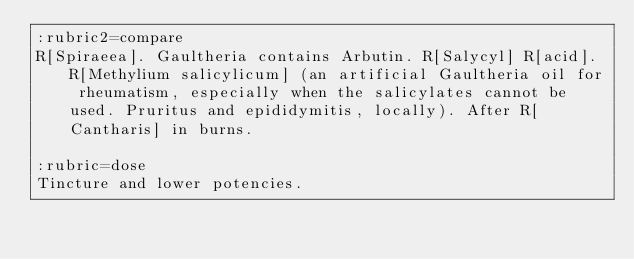Convert code to text. <code><loc_0><loc_0><loc_500><loc_500><_ObjectiveC_>:rubric2=compare
R[Spiraeea]. Gaultheria contains Arbutin. R[Salycyl] R[acid]. R[Methylium salicylicum] (an artificial Gaultheria oil for rheumatism, especially when the salicylates cannot be used. Pruritus and epididymitis, locally). After R[Cantharis] in burns.

:rubric=dose
Tincture and lower potencies.

</code> 